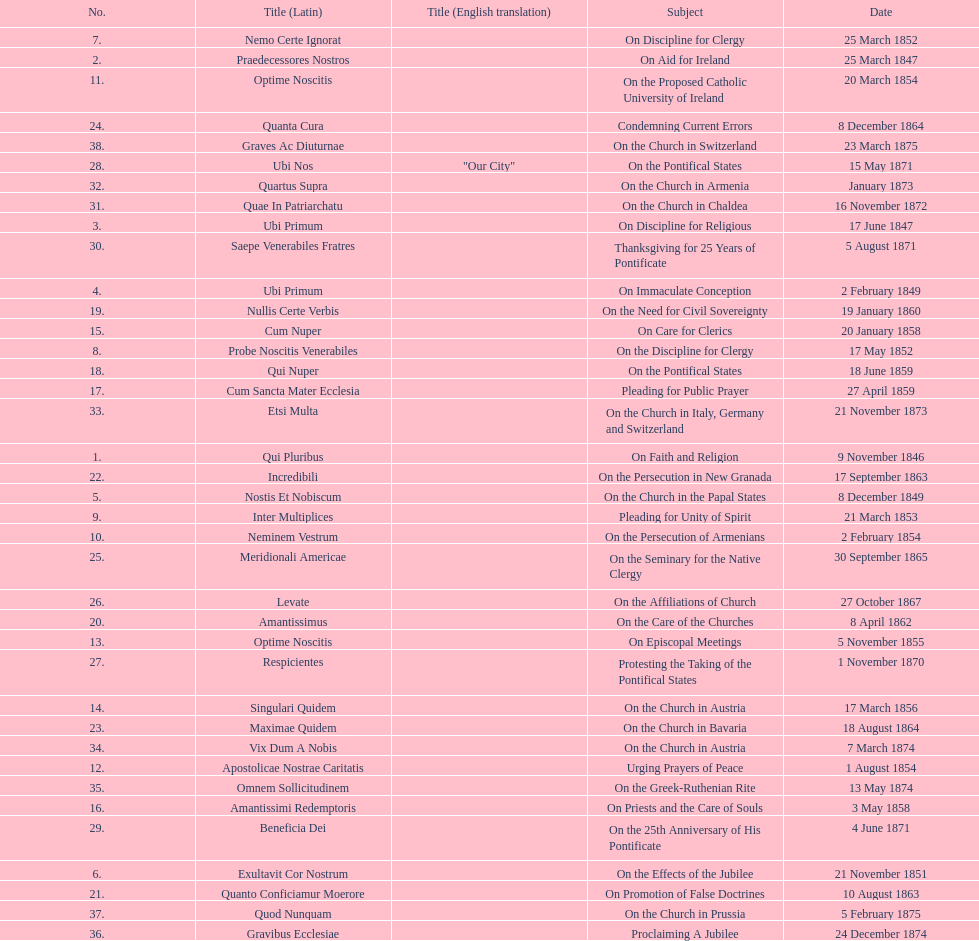Latin title of the encyclical before the encyclical with the subject "on the church in bavaria" Incredibili. 